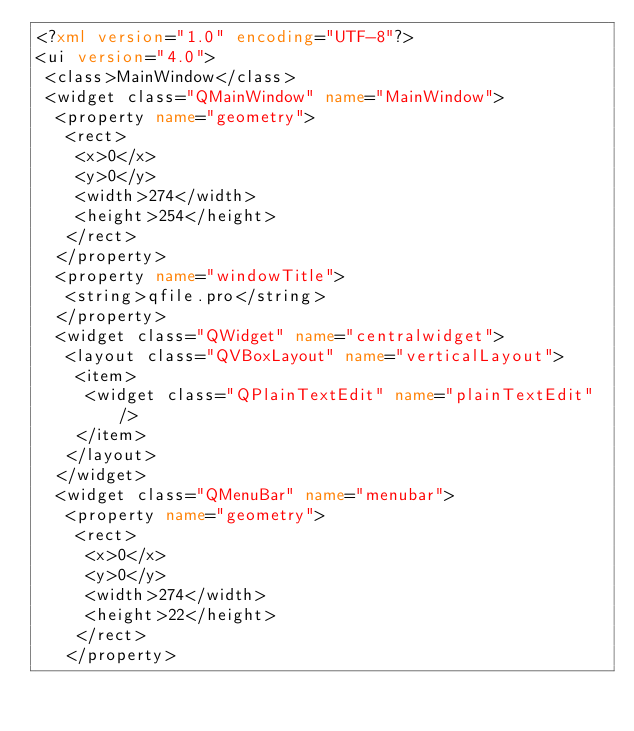Convert code to text. <code><loc_0><loc_0><loc_500><loc_500><_XML_><?xml version="1.0" encoding="UTF-8"?>
<ui version="4.0">
 <class>MainWindow</class>
 <widget class="QMainWindow" name="MainWindow">
  <property name="geometry">
   <rect>
    <x>0</x>
    <y>0</y>
    <width>274</width>
    <height>254</height>
   </rect>
  </property>
  <property name="windowTitle">
   <string>qfile.pro</string>
  </property>
  <widget class="QWidget" name="centralwidget">
   <layout class="QVBoxLayout" name="verticalLayout">
    <item>
     <widget class="QPlainTextEdit" name="plainTextEdit"/>
    </item>
   </layout>
  </widget>
  <widget class="QMenuBar" name="menubar">
   <property name="geometry">
    <rect>
     <x>0</x>
     <y>0</y>
     <width>274</width>
     <height>22</height>
    </rect>
   </property></code> 